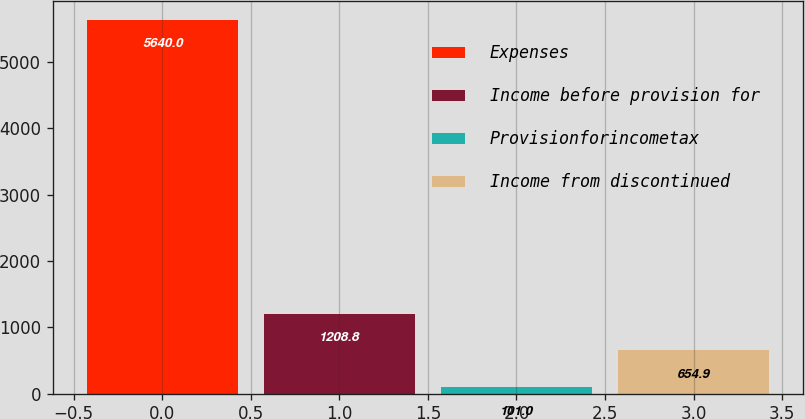Convert chart to OTSL. <chart><loc_0><loc_0><loc_500><loc_500><bar_chart><fcel>Expenses<fcel>Income before provision for<fcel>Provisionforincometax<fcel>Income from discontinued<nl><fcel>5640<fcel>1208.8<fcel>101<fcel>654.9<nl></chart> 